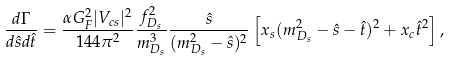<formula> <loc_0><loc_0><loc_500><loc_500>\frac { d \Gamma } { d \hat { s } d \hat { t } } = \frac { \alpha G _ { F } ^ { 2 } | V _ { c s } | ^ { 2 } } { 1 4 4 \pi ^ { 2 } } \frac { f _ { D _ { s } } ^ { 2 } } { m _ { D _ { s } } ^ { 3 } } \frac { \hat { s } } { ( m _ { D _ { s } } ^ { 2 } - \hat { s } ) ^ { 2 } } \left [ x _ { s } ( m _ { D _ { s } } ^ { 2 } - \hat { s } - \hat { t } ) ^ { 2 } + x _ { c } \hat { t } ^ { 2 } \right ] ,</formula> 